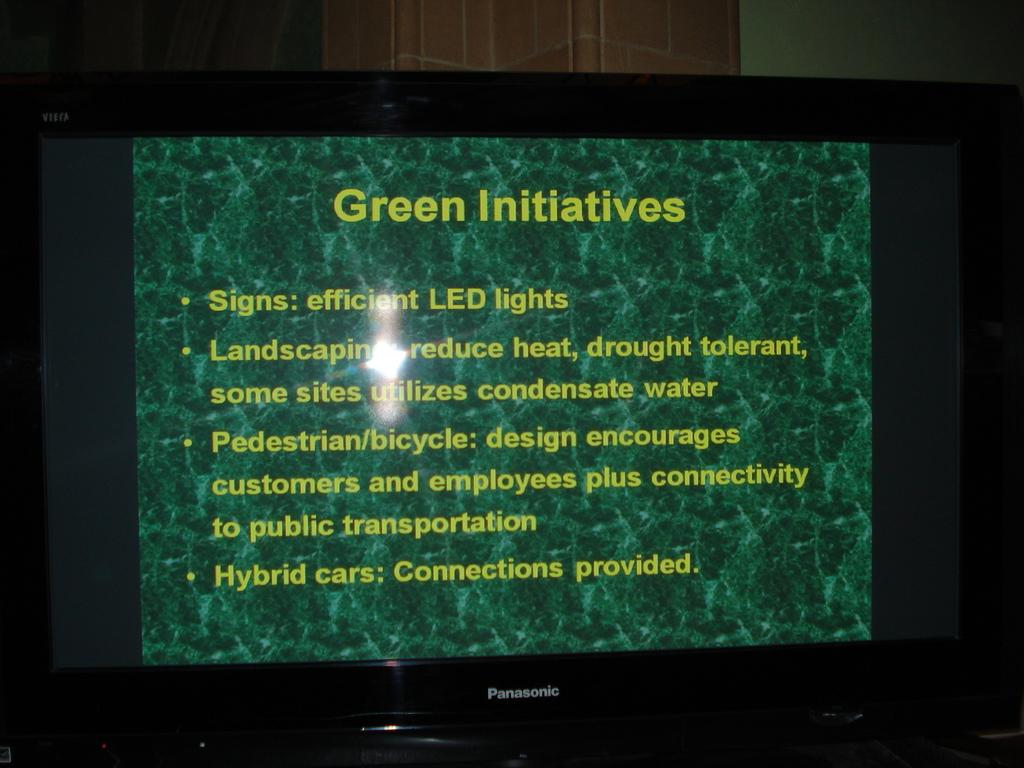<image>
Present a compact description of the photo's key features. A Panasonic screen shows a slide that says Green Initiatives. 